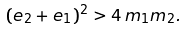Convert formula to latex. <formula><loc_0><loc_0><loc_500><loc_500>( e _ { 2 } + e _ { 1 } ) ^ { 2 } > 4 \, m _ { 1 } m _ { 2 } .</formula> 